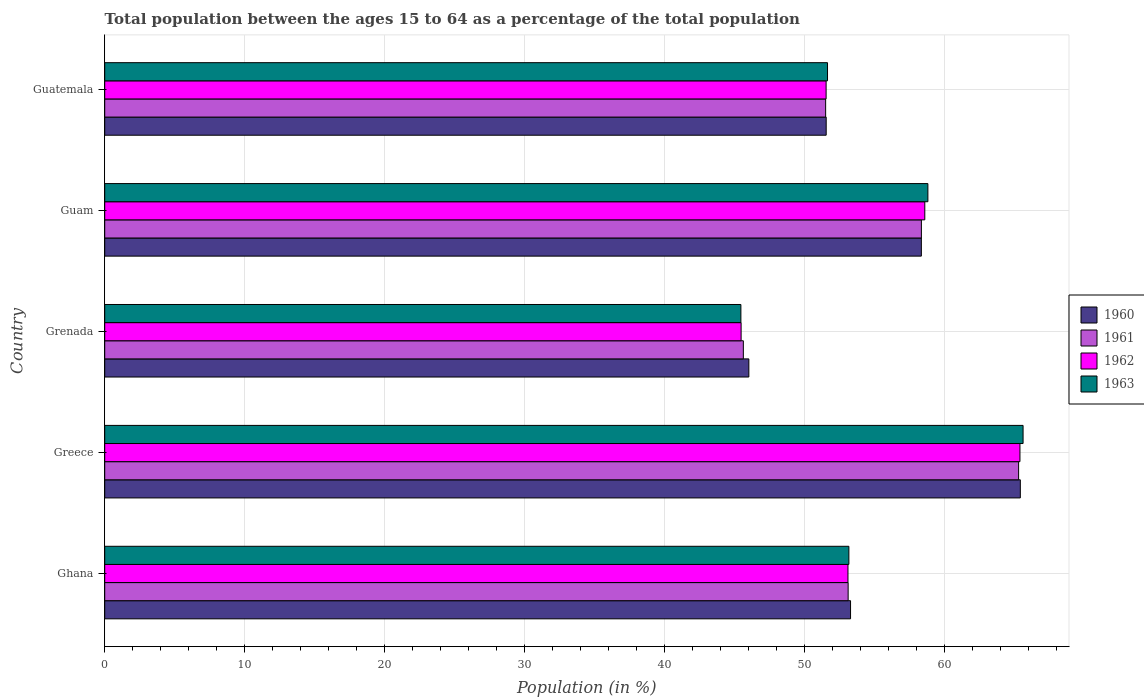How many different coloured bars are there?
Make the answer very short. 4. Are the number of bars on each tick of the Y-axis equal?
Your answer should be compact. Yes. How many bars are there on the 1st tick from the top?
Make the answer very short. 4. How many bars are there on the 5th tick from the bottom?
Offer a very short reply. 4. What is the label of the 5th group of bars from the top?
Your response must be concise. Ghana. In how many cases, is the number of bars for a given country not equal to the number of legend labels?
Offer a very short reply. 0. What is the percentage of the population ages 15 to 64 in 1961 in Guatemala?
Give a very brief answer. 51.5. Across all countries, what is the maximum percentage of the population ages 15 to 64 in 1962?
Provide a short and direct response. 65.38. Across all countries, what is the minimum percentage of the population ages 15 to 64 in 1961?
Your response must be concise. 45.62. In which country was the percentage of the population ages 15 to 64 in 1961 maximum?
Keep it short and to the point. Greece. In which country was the percentage of the population ages 15 to 64 in 1960 minimum?
Give a very brief answer. Grenada. What is the total percentage of the population ages 15 to 64 in 1963 in the graph?
Make the answer very short. 274.65. What is the difference between the percentage of the population ages 15 to 64 in 1961 in Greece and that in Guatemala?
Provide a succinct answer. 13.78. What is the difference between the percentage of the population ages 15 to 64 in 1962 in Grenada and the percentage of the population ages 15 to 64 in 1960 in Guam?
Provide a succinct answer. -12.88. What is the average percentage of the population ages 15 to 64 in 1962 per country?
Give a very brief answer. 54.81. What is the difference between the percentage of the population ages 15 to 64 in 1960 and percentage of the population ages 15 to 64 in 1961 in Guatemala?
Offer a very short reply. 0.04. In how many countries, is the percentage of the population ages 15 to 64 in 1962 greater than 58 ?
Offer a very short reply. 2. What is the ratio of the percentage of the population ages 15 to 64 in 1961 in Greece to that in Guam?
Offer a terse response. 1.12. What is the difference between the highest and the second highest percentage of the population ages 15 to 64 in 1963?
Ensure brevity in your answer.  6.8. What is the difference between the highest and the lowest percentage of the population ages 15 to 64 in 1961?
Your answer should be compact. 19.66. How many bars are there?
Ensure brevity in your answer.  20. Are all the bars in the graph horizontal?
Make the answer very short. Yes. How many countries are there in the graph?
Provide a short and direct response. 5. Does the graph contain grids?
Offer a very short reply. Yes. How many legend labels are there?
Offer a terse response. 4. How are the legend labels stacked?
Provide a succinct answer. Vertical. What is the title of the graph?
Provide a succinct answer. Total population between the ages 15 to 64 as a percentage of the total population. What is the label or title of the X-axis?
Ensure brevity in your answer.  Population (in %). What is the label or title of the Y-axis?
Offer a terse response. Country. What is the Population (in %) of 1960 in Ghana?
Ensure brevity in your answer.  53.28. What is the Population (in %) in 1961 in Ghana?
Your response must be concise. 53.11. What is the Population (in %) in 1962 in Ghana?
Your response must be concise. 53.1. What is the Population (in %) in 1963 in Ghana?
Offer a very short reply. 53.16. What is the Population (in %) of 1960 in Greece?
Your answer should be very brief. 65.41. What is the Population (in %) of 1961 in Greece?
Offer a very short reply. 65.29. What is the Population (in %) in 1962 in Greece?
Provide a succinct answer. 65.38. What is the Population (in %) of 1963 in Greece?
Your response must be concise. 65.61. What is the Population (in %) in 1960 in Grenada?
Offer a terse response. 46.01. What is the Population (in %) in 1961 in Grenada?
Give a very brief answer. 45.62. What is the Population (in %) of 1962 in Grenada?
Offer a very short reply. 45.46. What is the Population (in %) of 1963 in Grenada?
Provide a succinct answer. 45.45. What is the Population (in %) of 1960 in Guam?
Keep it short and to the point. 58.34. What is the Population (in %) of 1961 in Guam?
Give a very brief answer. 58.34. What is the Population (in %) of 1962 in Guam?
Your response must be concise. 58.58. What is the Population (in %) of 1963 in Guam?
Provide a succinct answer. 58.81. What is the Population (in %) of 1960 in Guatemala?
Your answer should be very brief. 51.54. What is the Population (in %) in 1961 in Guatemala?
Keep it short and to the point. 51.5. What is the Population (in %) of 1962 in Guatemala?
Make the answer very short. 51.53. What is the Population (in %) of 1963 in Guatemala?
Give a very brief answer. 51.63. Across all countries, what is the maximum Population (in %) of 1960?
Make the answer very short. 65.41. Across all countries, what is the maximum Population (in %) of 1961?
Provide a short and direct response. 65.29. Across all countries, what is the maximum Population (in %) of 1962?
Make the answer very short. 65.38. Across all countries, what is the maximum Population (in %) in 1963?
Offer a very short reply. 65.61. Across all countries, what is the minimum Population (in %) of 1960?
Your answer should be very brief. 46.01. Across all countries, what is the minimum Population (in %) in 1961?
Provide a short and direct response. 45.62. Across all countries, what is the minimum Population (in %) in 1962?
Make the answer very short. 45.46. Across all countries, what is the minimum Population (in %) of 1963?
Your answer should be compact. 45.45. What is the total Population (in %) in 1960 in the graph?
Offer a very short reply. 274.58. What is the total Population (in %) of 1961 in the graph?
Your answer should be very brief. 273.86. What is the total Population (in %) of 1962 in the graph?
Give a very brief answer. 274.06. What is the total Population (in %) in 1963 in the graph?
Make the answer very short. 274.65. What is the difference between the Population (in %) in 1960 in Ghana and that in Greece?
Your answer should be compact. -12.13. What is the difference between the Population (in %) in 1961 in Ghana and that in Greece?
Give a very brief answer. -12.18. What is the difference between the Population (in %) of 1962 in Ghana and that in Greece?
Offer a terse response. -12.29. What is the difference between the Population (in %) in 1963 in Ghana and that in Greece?
Provide a short and direct response. -12.44. What is the difference between the Population (in %) in 1960 in Ghana and that in Grenada?
Ensure brevity in your answer.  7.27. What is the difference between the Population (in %) in 1961 in Ghana and that in Grenada?
Offer a terse response. 7.49. What is the difference between the Population (in %) of 1962 in Ghana and that in Grenada?
Give a very brief answer. 7.63. What is the difference between the Population (in %) of 1963 in Ghana and that in Grenada?
Your answer should be very brief. 7.71. What is the difference between the Population (in %) in 1960 in Ghana and that in Guam?
Provide a succinct answer. -5.06. What is the difference between the Population (in %) of 1961 in Ghana and that in Guam?
Provide a succinct answer. -5.23. What is the difference between the Population (in %) of 1962 in Ghana and that in Guam?
Your answer should be very brief. -5.49. What is the difference between the Population (in %) of 1963 in Ghana and that in Guam?
Make the answer very short. -5.64. What is the difference between the Population (in %) of 1960 in Ghana and that in Guatemala?
Provide a short and direct response. 1.74. What is the difference between the Population (in %) of 1961 in Ghana and that in Guatemala?
Provide a succinct answer. 1.61. What is the difference between the Population (in %) of 1962 in Ghana and that in Guatemala?
Offer a terse response. 1.56. What is the difference between the Population (in %) of 1963 in Ghana and that in Guatemala?
Offer a very short reply. 1.53. What is the difference between the Population (in %) of 1960 in Greece and that in Grenada?
Ensure brevity in your answer.  19.39. What is the difference between the Population (in %) of 1961 in Greece and that in Grenada?
Provide a short and direct response. 19.66. What is the difference between the Population (in %) in 1962 in Greece and that in Grenada?
Your answer should be compact. 19.92. What is the difference between the Population (in %) in 1963 in Greece and that in Grenada?
Give a very brief answer. 20.16. What is the difference between the Population (in %) of 1960 in Greece and that in Guam?
Provide a succinct answer. 7.07. What is the difference between the Population (in %) in 1961 in Greece and that in Guam?
Keep it short and to the point. 6.94. What is the difference between the Population (in %) in 1962 in Greece and that in Guam?
Ensure brevity in your answer.  6.8. What is the difference between the Population (in %) in 1963 in Greece and that in Guam?
Offer a terse response. 6.8. What is the difference between the Population (in %) in 1960 in Greece and that in Guatemala?
Your response must be concise. 13.87. What is the difference between the Population (in %) of 1961 in Greece and that in Guatemala?
Offer a very short reply. 13.78. What is the difference between the Population (in %) of 1962 in Greece and that in Guatemala?
Keep it short and to the point. 13.85. What is the difference between the Population (in %) of 1963 in Greece and that in Guatemala?
Your response must be concise. 13.97. What is the difference between the Population (in %) in 1960 in Grenada and that in Guam?
Ensure brevity in your answer.  -12.32. What is the difference between the Population (in %) of 1961 in Grenada and that in Guam?
Offer a very short reply. -12.72. What is the difference between the Population (in %) in 1962 in Grenada and that in Guam?
Provide a short and direct response. -13.12. What is the difference between the Population (in %) in 1963 in Grenada and that in Guam?
Keep it short and to the point. -13.36. What is the difference between the Population (in %) of 1960 in Grenada and that in Guatemala?
Keep it short and to the point. -5.53. What is the difference between the Population (in %) in 1961 in Grenada and that in Guatemala?
Make the answer very short. -5.88. What is the difference between the Population (in %) of 1962 in Grenada and that in Guatemala?
Make the answer very short. -6.07. What is the difference between the Population (in %) of 1963 in Grenada and that in Guatemala?
Your answer should be very brief. -6.19. What is the difference between the Population (in %) of 1960 in Guam and that in Guatemala?
Provide a short and direct response. 6.8. What is the difference between the Population (in %) in 1961 in Guam and that in Guatemala?
Your answer should be compact. 6.84. What is the difference between the Population (in %) of 1962 in Guam and that in Guatemala?
Give a very brief answer. 7.05. What is the difference between the Population (in %) of 1963 in Guam and that in Guatemala?
Provide a short and direct response. 7.17. What is the difference between the Population (in %) of 1960 in Ghana and the Population (in %) of 1961 in Greece?
Make the answer very short. -12.01. What is the difference between the Population (in %) in 1960 in Ghana and the Population (in %) in 1962 in Greece?
Keep it short and to the point. -12.1. What is the difference between the Population (in %) in 1960 in Ghana and the Population (in %) in 1963 in Greece?
Provide a succinct answer. -12.33. What is the difference between the Population (in %) in 1961 in Ghana and the Population (in %) in 1962 in Greece?
Your answer should be compact. -12.27. What is the difference between the Population (in %) in 1961 in Ghana and the Population (in %) in 1963 in Greece?
Give a very brief answer. -12.5. What is the difference between the Population (in %) of 1962 in Ghana and the Population (in %) of 1963 in Greece?
Provide a short and direct response. -12.51. What is the difference between the Population (in %) in 1960 in Ghana and the Population (in %) in 1961 in Grenada?
Keep it short and to the point. 7.66. What is the difference between the Population (in %) of 1960 in Ghana and the Population (in %) of 1962 in Grenada?
Make the answer very short. 7.82. What is the difference between the Population (in %) of 1960 in Ghana and the Population (in %) of 1963 in Grenada?
Offer a terse response. 7.83. What is the difference between the Population (in %) of 1961 in Ghana and the Population (in %) of 1962 in Grenada?
Keep it short and to the point. 7.65. What is the difference between the Population (in %) of 1961 in Ghana and the Population (in %) of 1963 in Grenada?
Offer a very short reply. 7.66. What is the difference between the Population (in %) of 1962 in Ghana and the Population (in %) of 1963 in Grenada?
Give a very brief answer. 7.65. What is the difference between the Population (in %) in 1960 in Ghana and the Population (in %) in 1961 in Guam?
Give a very brief answer. -5.06. What is the difference between the Population (in %) of 1960 in Ghana and the Population (in %) of 1962 in Guam?
Offer a terse response. -5.3. What is the difference between the Population (in %) of 1960 in Ghana and the Population (in %) of 1963 in Guam?
Make the answer very short. -5.53. What is the difference between the Population (in %) in 1961 in Ghana and the Population (in %) in 1962 in Guam?
Make the answer very short. -5.48. What is the difference between the Population (in %) of 1961 in Ghana and the Population (in %) of 1963 in Guam?
Offer a terse response. -5.7. What is the difference between the Population (in %) of 1962 in Ghana and the Population (in %) of 1963 in Guam?
Keep it short and to the point. -5.71. What is the difference between the Population (in %) in 1960 in Ghana and the Population (in %) in 1961 in Guatemala?
Your answer should be very brief. 1.78. What is the difference between the Population (in %) of 1960 in Ghana and the Population (in %) of 1962 in Guatemala?
Your answer should be compact. 1.75. What is the difference between the Population (in %) in 1960 in Ghana and the Population (in %) in 1963 in Guatemala?
Your answer should be compact. 1.65. What is the difference between the Population (in %) in 1961 in Ghana and the Population (in %) in 1962 in Guatemala?
Offer a terse response. 1.57. What is the difference between the Population (in %) in 1961 in Ghana and the Population (in %) in 1963 in Guatemala?
Keep it short and to the point. 1.47. What is the difference between the Population (in %) in 1962 in Ghana and the Population (in %) in 1963 in Guatemala?
Your answer should be very brief. 1.46. What is the difference between the Population (in %) in 1960 in Greece and the Population (in %) in 1961 in Grenada?
Provide a succinct answer. 19.79. What is the difference between the Population (in %) of 1960 in Greece and the Population (in %) of 1962 in Grenada?
Provide a succinct answer. 19.95. What is the difference between the Population (in %) in 1960 in Greece and the Population (in %) in 1963 in Grenada?
Keep it short and to the point. 19.96. What is the difference between the Population (in %) of 1961 in Greece and the Population (in %) of 1962 in Grenada?
Offer a very short reply. 19.82. What is the difference between the Population (in %) in 1961 in Greece and the Population (in %) in 1963 in Grenada?
Give a very brief answer. 19.84. What is the difference between the Population (in %) of 1962 in Greece and the Population (in %) of 1963 in Grenada?
Provide a succinct answer. 19.94. What is the difference between the Population (in %) of 1960 in Greece and the Population (in %) of 1961 in Guam?
Keep it short and to the point. 7.07. What is the difference between the Population (in %) of 1960 in Greece and the Population (in %) of 1962 in Guam?
Your answer should be very brief. 6.82. What is the difference between the Population (in %) in 1960 in Greece and the Population (in %) in 1963 in Guam?
Provide a succinct answer. 6.6. What is the difference between the Population (in %) of 1961 in Greece and the Population (in %) of 1962 in Guam?
Offer a terse response. 6.7. What is the difference between the Population (in %) in 1961 in Greece and the Population (in %) in 1963 in Guam?
Offer a terse response. 6.48. What is the difference between the Population (in %) in 1962 in Greece and the Population (in %) in 1963 in Guam?
Provide a succinct answer. 6.58. What is the difference between the Population (in %) of 1960 in Greece and the Population (in %) of 1961 in Guatemala?
Make the answer very short. 13.91. What is the difference between the Population (in %) of 1960 in Greece and the Population (in %) of 1962 in Guatemala?
Offer a terse response. 13.87. What is the difference between the Population (in %) in 1960 in Greece and the Population (in %) in 1963 in Guatemala?
Provide a short and direct response. 13.77. What is the difference between the Population (in %) in 1961 in Greece and the Population (in %) in 1962 in Guatemala?
Your answer should be compact. 13.75. What is the difference between the Population (in %) of 1961 in Greece and the Population (in %) of 1963 in Guatemala?
Provide a succinct answer. 13.65. What is the difference between the Population (in %) of 1962 in Greece and the Population (in %) of 1963 in Guatemala?
Your answer should be compact. 13.75. What is the difference between the Population (in %) of 1960 in Grenada and the Population (in %) of 1961 in Guam?
Make the answer very short. -12.33. What is the difference between the Population (in %) of 1960 in Grenada and the Population (in %) of 1962 in Guam?
Make the answer very short. -12.57. What is the difference between the Population (in %) in 1960 in Grenada and the Population (in %) in 1963 in Guam?
Keep it short and to the point. -12.79. What is the difference between the Population (in %) of 1961 in Grenada and the Population (in %) of 1962 in Guam?
Keep it short and to the point. -12.96. What is the difference between the Population (in %) of 1961 in Grenada and the Population (in %) of 1963 in Guam?
Your answer should be compact. -13.18. What is the difference between the Population (in %) of 1962 in Grenada and the Population (in %) of 1963 in Guam?
Your answer should be compact. -13.34. What is the difference between the Population (in %) of 1960 in Grenada and the Population (in %) of 1961 in Guatemala?
Offer a terse response. -5.49. What is the difference between the Population (in %) in 1960 in Grenada and the Population (in %) in 1962 in Guatemala?
Your answer should be very brief. -5.52. What is the difference between the Population (in %) in 1960 in Grenada and the Population (in %) in 1963 in Guatemala?
Make the answer very short. -5.62. What is the difference between the Population (in %) of 1961 in Grenada and the Population (in %) of 1962 in Guatemala?
Provide a succinct answer. -5.91. What is the difference between the Population (in %) in 1961 in Grenada and the Population (in %) in 1963 in Guatemala?
Ensure brevity in your answer.  -6.01. What is the difference between the Population (in %) in 1962 in Grenada and the Population (in %) in 1963 in Guatemala?
Your answer should be compact. -6.17. What is the difference between the Population (in %) in 1960 in Guam and the Population (in %) in 1961 in Guatemala?
Give a very brief answer. 6.84. What is the difference between the Population (in %) of 1960 in Guam and the Population (in %) of 1962 in Guatemala?
Keep it short and to the point. 6.8. What is the difference between the Population (in %) of 1960 in Guam and the Population (in %) of 1963 in Guatemala?
Provide a short and direct response. 6.7. What is the difference between the Population (in %) in 1961 in Guam and the Population (in %) in 1962 in Guatemala?
Provide a short and direct response. 6.81. What is the difference between the Population (in %) of 1961 in Guam and the Population (in %) of 1963 in Guatemala?
Keep it short and to the point. 6.71. What is the difference between the Population (in %) of 1962 in Guam and the Population (in %) of 1963 in Guatemala?
Make the answer very short. 6.95. What is the average Population (in %) of 1960 per country?
Keep it short and to the point. 54.92. What is the average Population (in %) of 1961 per country?
Offer a terse response. 54.77. What is the average Population (in %) of 1962 per country?
Keep it short and to the point. 54.81. What is the average Population (in %) in 1963 per country?
Provide a short and direct response. 54.93. What is the difference between the Population (in %) of 1960 and Population (in %) of 1961 in Ghana?
Give a very brief answer. 0.17. What is the difference between the Population (in %) of 1960 and Population (in %) of 1962 in Ghana?
Provide a succinct answer. 0.18. What is the difference between the Population (in %) of 1960 and Population (in %) of 1963 in Ghana?
Provide a succinct answer. 0.12. What is the difference between the Population (in %) of 1961 and Population (in %) of 1962 in Ghana?
Your response must be concise. 0.01. What is the difference between the Population (in %) of 1961 and Population (in %) of 1963 in Ghana?
Your response must be concise. -0.05. What is the difference between the Population (in %) of 1962 and Population (in %) of 1963 in Ghana?
Your answer should be compact. -0.06. What is the difference between the Population (in %) of 1960 and Population (in %) of 1961 in Greece?
Provide a succinct answer. 0.12. What is the difference between the Population (in %) in 1960 and Population (in %) in 1962 in Greece?
Offer a terse response. 0.03. What is the difference between the Population (in %) in 1960 and Population (in %) in 1963 in Greece?
Provide a short and direct response. -0.2. What is the difference between the Population (in %) in 1961 and Population (in %) in 1962 in Greece?
Make the answer very short. -0.1. What is the difference between the Population (in %) in 1961 and Population (in %) in 1963 in Greece?
Offer a terse response. -0.32. What is the difference between the Population (in %) of 1962 and Population (in %) of 1963 in Greece?
Your response must be concise. -0.22. What is the difference between the Population (in %) of 1960 and Population (in %) of 1961 in Grenada?
Your answer should be compact. 0.39. What is the difference between the Population (in %) of 1960 and Population (in %) of 1962 in Grenada?
Keep it short and to the point. 0.55. What is the difference between the Population (in %) in 1960 and Population (in %) in 1963 in Grenada?
Provide a succinct answer. 0.57. What is the difference between the Population (in %) of 1961 and Population (in %) of 1962 in Grenada?
Give a very brief answer. 0.16. What is the difference between the Population (in %) of 1961 and Population (in %) of 1963 in Grenada?
Ensure brevity in your answer.  0.18. What is the difference between the Population (in %) of 1962 and Population (in %) of 1963 in Grenada?
Your answer should be compact. 0.02. What is the difference between the Population (in %) in 1960 and Population (in %) in 1961 in Guam?
Ensure brevity in your answer.  -0. What is the difference between the Population (in %) in 1960 and Population (in %) in 1962 in Guam?
Provide a succinct answer. -0.25. What is the difference between the Population (in %) in 1960 and Population (in %) in 1963 in Guam?
Provide a short and direct response. -0.47. What is the difference between the Population (in %) of 1961 and Population (in %) of 1962 in Guam?
Your response must be concise. -0.24. What is the difference between the Population (in %) in 1961 and Population (in %) in 1963 in Guam?
Offer a very short reply. -0.46. What is the difference between the Population (in %) of 1962 and Population (in %) of 1963 in Guam?
Ensure brevity in your answer.  -0.22. What is the difference between the Population (in %) of 1960 and Population (in %) of 1961 in Guatemala?
Keep it short and to the point. 0.04. What is the difference between the Population (in %) of 1960 and Population (in %) of 1962 in Guatemala?
Your answer should be very brief. 0.01. What is the difference between the Population (in %) of 1960 and Population (in %) of 1963 in Guatemala?
Provide a short and direct response. -0.09. What is the difference between the Population (in %) in 1961 and Population (in %) in 1962 in Guatemala?
Ensure brevity in your answer.  -0.03. What is the difference between the Population (in %) in 1961 and Population (in %) in 1963 in Guatemala?
Give a very brief answer. -0.13. What is the difference between the Population (in %) in 1962 and Population (in %) in 1963 in Guatemala?
Your answer should be compact. -0.1. What is the ratio of the Population (in %) of 1960 in Ghana to that in Greece?
Make the answer very short. 0.81. What is the ratio of the Population (in %) of 1961 in Ghana to that in Greece?
Your answer should be very brief. 0.81. What is the ratio of the Population (in %) of 1962 in Ghana to that in Greece?
Make the answer very short. 0.81. What is the ratio of the Population (in %) of 1963 in Ghana to that in Greece?
Your answer should be very brief. 0.81. What is the ratio of the Population (in %) of 1960 in Ghana to that in Grenada?
Offer a very short reply. 1.16. What is the ratio of the Population (in %) of 1961 in Ghana to that in Grenada?
Offer a very short reply. 1.16. What is the ratio of the Population (in %) of 1962 in Ghana to that in Grenada?
Make the answer very short. 1.17. What is the ratio of the Population (in %) in 1963 in Ghana to that in Grenada?
Make the answer very short. 1.17. What is the ratio of the Population (in %) in 1960 in Ghana to that in Guam?
Keep it short and to the point. 0.91. What is the ratio of the Population (in %) of 1961 in Ghana to that in Guam?
Give a very brief answer. 0.91. What is the ratio of the Population (in %) in 1962 in Ghana to that in Guam?
Offer a very short reply. 0.91. What is the ratio of the Population (in %) in 1963 in Ghana to that in Guam?
Provide a succinct answer. 0.9. What is the ratio of the Population (in %) of 1960 in Ghana to that in Guatemala?
Offer a terse response. 1.03. What is the ratio of the Population (in %) of 1961 in Ghana to that in Guatemala?
Your response must be concise. 1.03. What is the ratio of the Population (in %) in 1962 in Ghana to that in Guatemala?
Your answer should be very brief. 1.03. What is the ratio of the Population (in %) in 1963 in Ghana to that in Guatemala?
Provide a succinct answer. 1.03. What is the ratio of the Population (in %) in 1960 in Greece to that in Grenada?
Your answer should be very brief. 1.42. What is the ratio of the Population (in %) of 1961 in Greece to that in Grenada?
Provide a succinct answer. 1.43. What is the ratio of the Population (in %) of 1962 in Greece to that in Grenada?
Make the answer very short. 1.44. What is the ratio of the Population (in %) of 1963 in Greece to that in Grenada?
Provide a short and direct response. 1.44. What is the ratio of the Population (in %) in 1960 in Greece to that in Guam?
Make the answer very short. 1.12. What is the ratio of the Population (in %) of 1961 in Greece to that in Guam?
Provide a succinct answer. 1.12. What is the ratio of the Population (in %) in 1962 in Greece to that in Guam?
Ensure brevity in your answer.  1.12. What is the ratio of the Population (in %) of 1963 in Greece to that in Guam?
Your answer should be very brief. 1.12. What is the ratio of the Population (in %) in 1960 in Greece to that in Guatemala?
Your answer should be compact. 1.27. What is the ratio of the Population (in %) in 1961 in Greece to that in Guatemala?
Your answer should be very brief. 1.27. What is the ratio of the Population (in %) of 1962 in Greece to that in Guatemala?
Offer a very short reply. 1.27. What is the ratio of the Population (in %) in 1963 in Greece to that in Guatemala?
Make the answer very short. 1.27. What is the ratio of the Population (in %) of 1960 in Grenada to that in Guam?
Your answer should be very brief. 0.79. What is the ratio of the Population (in %) of 1961 in Grenada to that in Guam?
Provide a succinct answer. 0.78. What is the ratio of the Population (in %) in 1962 in Grenada to that in Guam?
Your answer should be compact. 0.78. What is the ratio of the Population (in %) in 1963 in Grenada to that in Guam?
Ensure brevity in your answer.  0.77. What is the ratio of the Population (in %) of 1960 in Grenada to that in Guatemala?
Make the answer very short. 0.89. What is the ratio of the Population (in %) of 1961 in Grenada to that in Guatemala?
Your answer should be compact. 0.89. What is the ratio of the Population (in %) in 1962 in Grenada to that in Guatemala?
Provide a succinct answer. 0.88. What is the ratio of the Population (in %) in 1963 in Grenada to that in Guatemala?
Ensure brevity in your answer.  0.88. What is the ratio of the Population (in %) of 1960 in Guam to that in Guatemala?
Ensure brevity in your answer.  1.13. What is the ratio of the Population (in %) in 1961 in Guam to that in Guatemala?
Your answer should be very brief. 1.13. What is the ratio of the Population (in %) in 1962 in Guam to that in Guatemala?
Ensure brevity in your answer.  1.14. What is the ratio of the Population (in %) in 1963 in Guam to that in Guatemala?
Your response must be concise. 1.14. What is the difference between the highest and the second highest Population (in %) in 1960?
Keep it short and to the point. 7.07. What is the difference between the highest and the second highest Population (in %) in 1961?
Keep it short and to the point. 6.94. What is the difference between the highest and the second highest Population (in %) of 1962?
Give a very brief answer. 6.8. What is the difference between the highest and the second highest Population (in %) in 1963?
Your response must be concise. 6.8. What is the difference between the highest and the lowest Population (in %) in 1960?
Provide a short and direct response. 19.39. What is the difference between the highest and the lowest Population (in %) of 1961?
Offer a very short reply. 19.66. What is the difference between the highest and the lowest Population (in %) of 1962?
Ensure brevity in your answer.  19.92. What is the difference between the highest and the lowest Population (in %) in 1963?
Make the answer very short. 20.16. 